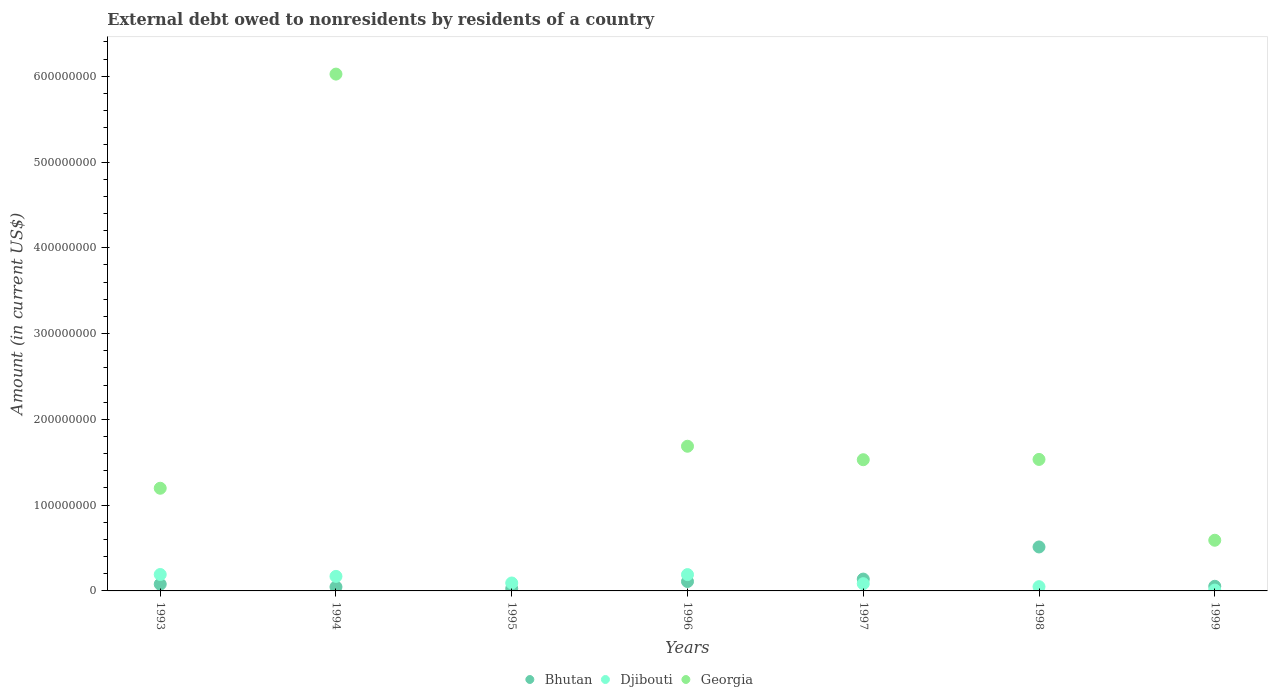What is the external debt owed by residents in Bhutan in 1995?
Provide a short and direct response. 2.72e+06. Across all years, what is the maximum external debt owed by residents in Bhutan?
Offer a terse response. 5.13e+07. Across all years, what is the minimum external debt owed by residents in Georgia?
Ensure brevity in your answer.  0. In which year was the external debt owed by residents in Djibouti maximum?
Provide a succinct answer. 1993. What is the total external debt owed by residents in Georgia in the graph?
Your answer should be compact. 1.26e+09. What is the difference between the external debt owed by residents in Djibouti in 1994 and that in 1995?
Ensure brevity in your answer.  7.70e+06. What is the difference between the external debt owed by residents in Djibouti in 1994 and the external debt owed by residents in Bhutan in 1997?
Provide a succinct answer. 3.14e+06. What is the average external debt owed by residents in Georgia per year?
Make the answer very short. 1.79e+08. In the year 1998, what is the difference between the external debt owed by residents in Djibouti and external debt owed by residents in Bhutan?
Offer a very short reply. -4.63e+07. In how many years, is the external debt owed by residents in Djibouti greater than 560000000 US$?
Your answer should be very brief. 0. What is the ratio of the external debt owed by residents in Djibouti in 1994 to that in 1997?
Keep it short and to the point. 2. Is the external debt owed by residents in Djibouti in 1994 less than that in 1999?
Give a very brief answer. No. What is the difference between the highest and the second highest external debt owed by residents in Bhutan?
Give a very brief answer. 3.75e+07. What is the difference between the highest and the lowest external debt owed by residents in Djibouti?
Keep it short and to the point. 1.82e+07. In how many years, is the external debt owed by residents in Bhutan greater than the average external debt owed by residents in Bhutan taken over all years?
Your response must be concise. 1. Is it the case that in every year, the sum of the external debt owed by residents in Bhutan and external debt owed by residents in Georgia  is greater than the external debt owed by residents in Djibouti?
Ensure brevity in your answer.  No. Does the external debt owed by residents in Bhutan monotonically increase over the years?
Your response must be concise. No. Is the external debt owed by residents in Bhutan strictly less than the external debt owed by residents in Georgia over the years?
Provide a succinct answer. No. How many dotlines are there?
Offer a very short reply. 3. Are the values on the major ticks of Y-axis written in scientific E-notation?
Offer a terse response. No. Does the graph contain grids?
Provide a succinct answer. No. How many legend labels are there?
Your response must be concise. 3. What is the title of the graph?
Offer a terse response. External debt owed to nonresidents by residents of a country. What is the label or title of the X-axis?
Make the answer very short. Years. What is the label or title of the Y-axis?
Offer a very short reply. Amount (in current US$). What is the Amount (in current US$) in Bhutan in 1993?
Offer a terse response. 7.85e+06. What is the Amount (in current US$) in Djibouti in 1993?
Your response must be concise. 1.91e+07. What is the Amount (in current US$) of Georgia in 1993?
Your answer should be compact. 1.20e+08. What is the Amount (in current US$) in Bhutan in 1994?
Provide a short and direct response. 4.67e+06. What is the Amount (in current US$) in Djibouti in 1994?
Give a very brief answer. 1.69e+07. What is the Amount (in current US$) of Georgia in 1994?
Provide a short and direct response. 6.03e+08. What is the Amount (in current US$) in Bhutan in 1995?
Keep it short and to the point. 2.72e+06. What is the Amount (in current US$) of Djibouti in 1995?
Offer a very short reply. 9.24e+06. What is the Amount (in current US$) in Bhutan in 1996?
Provide a succinct answer. 1.10e+07. What is the Amount (in current US$) of Djibouti in 1996?
Ensure brevity in your answer.  1.90e+07. What is the Amount (in current US$) in Georgia in 1996?
Keep it short and to the point. 1.69e+08. What is the Amount (in current US$) in Bhutan in 1997?
Keep it short and to the point. 1.38e+07. What is the Amount (in current US$) in Djibouti in 1997?
Ensure brevity in your answer.  8.45e+06. What is the Amount (in current US$) of Georgia in 1997?
Provide a succinct answer. 1.53e+08. What is the Amount (in current US$) in Bhutan in 1998?
Give a very brief answer. 5.13e+07. What is the Amount (in current US$) of Djibouti in 1998?
Keep it short and to the point. 4.94e+06. What is the Amount (in current US$) in Georgia in 1998?
Your response must be concise. 1.53e+08. What is the Amount (in current US$) of Bhutan in 1999?
Your answer should be compact. 5.40e+06. What is the Amount (in current US$) in Djibouti in 1999?
Provide a succinct answer. 9.88e+05. What is the Amount (in current US$) in Georgia in 1999?
Offer a very short reply. 5.91e+07. Across all years, what is the maximum Amount (in current US$) of Bhutan?
Your answer should be very brief. 5.13e+07. Across all years, what is the maximum Amount (in current US$) of Djibouti?
Your response must be concise. 1.91e+07. Across all years, what is the maximum Amount (in current US$) of Georgia?
Your response must be concise. 6.03e+08. Across all years, what is the minimum Amount (in current US$) in Bhutan?
Offer a very short reply. 2.72e+06. Across all years, what is the minimum Amount (in current US$) in Djibouti?
Your response must be concise. 9.88e+05. Across all years, what is the minimum Amount (in current US$) in Georgia?
Offer a very short reply. 0. What is the total Amount (in current US$) in Bhutan in the graph?
Offer a very short reply. 9.66e+07. What is the total Amount (in current US$) in Djibouti in the graph?
Give a very brief answer. 7.87e+07. What is the total Amount (in current US$) in Georgia in the graph?
Your answer should be very brief. 1.26e+09. What is the difference between the Amount (in current US$) of Bhutan in 1993 and that in 1994?
Offer a terse response. 3.19e+06. What is the difference between the Amount (in current US$) of Djibouti in 1993 and that in 1994?
Make the answer very short. 2.20e+06. What is the difference between the Amount (in current US$) in Georgia in 1993 and that in 1994?
Give a very brief answer. -4.83e+08. What is the difference between the Amount (in current US$) in Bhutan in 1993 and that in 1995?
Your response must be concise. 5.14e+06. What is the difference between the Amount (in current US$) in Djibouti in 1993 and that in 1995?
Provide a succinct answer. 9.91e+06. What is the difference between the Amount (in current US$) in Bhutan in 1993 and that in 1996?
Offer a terse response. -3.12e+06. What is the difference between the Amount (in current US$) of Djibouti in 1993 and that in 1996?
Ensure brevity in your answer.  1.13e+05. What is the difference between the Amount (in current US$) in Georgia in 1993 and that in 1996?
Your response must be concise. -4.90e+07. What is the difference between the Amount (in current US$) in Bhutan in 1993 and that in 1997?
Provide a short and direct response. -5.94e+06. What is the difference between the Amount (in current US$) in Djibouti in 1993 and that in 1997?
Provide a succinct answer. 1.07e+07. What is the difference between the Amount (in current US$) in Georgia in 1993 and that in 1997?
Provide a short and direct response. -3.33e+07. What is the difference between the Amount (in current US$) of Bhutan in 1993 and that in 1998?
Provide a succinct answer. -4.34e+07. What is the difference between the Amount (in current US$) of Djibouti in 1993 and that in 1998?
Ensure brevity in your answer.  1.42e+07. What is the difference between the Amount (in current US$) in Georgia in 1993 and that in 1998?
Provide a short and direct response. -3.36e+07. What is the difference between the Amount (in current US$) of Bhutan in 1993 and that in 1999?
Ensure brevity in your answer.  2.46e+06. What is the difference between the Amount (in current US$) of Djibouti in 1993 and that in 1999?
Provide a short and direct response. 1.82e+07. What is the difference between the Amount (in current US$) in Georgia in 1993 and that in 1999?
Give a very brief answer. 6.06e+07. What is the difference between the Amount (in current US$) of Bhutan in 1994 and that in 1995?
Keep it short and to the point. 1.95e+06. What is the difference between the Amount (in current US$) in Djibouti in 1994 and that in 1995?
Your answer should be compact. 7.70e+06. What is the difference between the Amount (in current US$) of Bhutan in 1994 and that in 1996?
Your answer should be very brief. -6.30e+06. What is the difference between the Amount (in current US$) of Djibouti in 1994 and that in 1996?
Your answer should be very brief. -2.09e+06. What is the difference between the Amount (in current US$) in Georgia in 1994 and that in 1996?
Your response must be concise. 4.34e+08. What is the difference between the Amount (in current US$) of Bhutan in 1994 and that in 1997?
Provide a short and direct response. -9.13e+06. What is the difference between the Amount (in current US$) of Djibouti in 1994 and that in 1997?
Keep it short and to the point. 8.49e+06. What is the difference between the Amount (in current US$) of Georgia in 1994 and that in 1997?
Your response must be concise. 4.50e+08. What is the difference between the Amount (in current US$) of Bhutan in 1994 and that in 1998?
Ensure brevity in your answer.  -4.66e+07. What is the difference between the Amount (in current US$) of Djibouti in 1994 and that in 1998?
Give a very brief answer. 1.20e+07. What is the difference between the Amount (in current US$) of Georgia in 1994 and that in 1998?
Your answer should be compact. 4.49e+08. What is the difference between the Amount (in current US$) of Bhutan in 1994 and that in 1999?
Offer a very short reply. -7.28e+05. What is the difference between the Amount (in current US$) in Djibouti in 1994 and that in 1999?
Keep it short and to the point. 1.60e+07. What is the difference between the Amount (in current US$) in Georgia in 1994 and that in 1999?
Your answer should be very brief. 5.43e+08. What is the difference between the Amount (in current US$) in Bhutan in 1995 and that in 1996?
Provide a succinct answer. -8.25e+06. What is the difference between the Amount (in current US$) in Djibouti in 1995 and that in 1996?
Your answer should be compact. -9.79e+06. What is the difference between the Amount (in current US$) in Bhutan in 1995 and that in 1997?
Provide a short and direct response. -1.11e+07. What is the difference between the Amount (in current US$) in Djibouti in 1995 and that in 1997?
Ensure brevity in your answer.  7.84e+05. What is the difference between the Amount (in current US$) in Bhutan in 1995 and that in 1998?
Provide a short and direct response. -4.85e+07. What is the difference between the Amount (in current US$) in Djibouti in 1995 and that in 1998?
Your answer should be very brief. 4.30e+06. What is the difference between the Amount (in current US$) of Bhutan in 1995 and that in 1999?
Offer a very short reply. -2.68e+06. What is the difference between the Amount (in current US$) of Djibouti in 1995 and that in 1999?
Your answer should be very brief. 8.25e+06. What is the difference between the Amount (in current US$) of Bhutan in 1996 and that in 1997?
Ensure brevity in your answer.  -2.83e+06. What is the difference between the Amount (in current US$) of Djibouti in 1996 and that in 1997?
Your answer should be compact. 1.06e+07. What is the difference between the Amount (in current US$) of Georgia in 1996 and that in 1997?
Offer a very short reply. 1.57e+07. What is the difference between the Amount (in current US$) of Bhutan in 1996 and that in 1998?
Give a very brief answer. -4.03e+07. What is the difference between the Amount (in current US$) in Djibouti in 1996 and that in 1998?
Give a very brief answer. 1.41e+07. What is the difference between the Amount (in current US$) in Georgia in 1996 and that in 1998?
Your response must be concise. 1.54e+07. What is the difference between the Amount (in current US$) in Bhutan in 1996 and that in 1999?
Provide a succinct answer. 5.57e+06. What is the difference between the Amount (in current US$) in Djibouti in 1996 and that in 1999?
Your answer should be very brief. 1.80e+07. What is the difference between the Amount (in current US$) of Georgia in 1996 and that in 1999?
Your response must be concise. 1.10e+08. What is the difference between the Amount (in current US$) of Bhutan in 1997 and that in 1998?
Your answer should be very brief. -3.75e+07. What is the difference between the Amount (in current US$) in Djibouti in 1997 and that in 1998?
Give a very brief answer. 3.51e+06. What is the difference between the Amount (in current US$) of Georgia in 1997 and that in 1998?
Make the answer very short. -3.48e+05. What is the difference between the Amount (in current US$) in Bhutan in 1997 and that in 1999?
Your response must be concise. 8.40e+06. What is the difference between the Amount (in current US$) in Djibouti in 1997 and that in 1999?
Keep it short and to the point. 7.47e+06. What is the difference between the Amount (in current US$) of Georgia in 1997 and that in 1999?
Provide a short and direct response. 9.39e+07. What is the difference between the Amount (in current US$) of Bhutan in 1998 and that in 1999?
Your answer should be very brief. 4.59e+07. What is the difference between the Amount (in current US$) of Djibouti in 1998 and that in 1999?
Make the answer very short. 3.96e+06. What is the difference between the Amount (in current US$) of Georgia in 1998 and that in 1999?
Offer a very short reply. 9.42e+07. What is the difference between the Amount (in current US$) of Bhutan in 1993 and the Amount (in current US$) of Djibouti in 1994?
Give a very brief answer. -9.09e+06. What is the difference between the Amount (in current US$) of Bhutan in 1993 and the Amount (in current US$) of Georgia in 1994?
Provide a short and direct response. -5.95e+08. What is the difference between the Amount (in current US$) of Djibouti in 1993 and the Amount (in current US$) of Georgia in 1994?
Provide a short and direct response. -5.83e+08. What is the difference between the Amount (in current US$) in Bhutan in 1993 and the Amount (in current US$) in Djibouti in 1995?
Provide a succinct answer. -1.38e+06. What is the difference between the Amount (in current US$) in Bhutan in 1993 and the Amount (in current US$) in Djibouti in 1996?
Make the answer very short. -1.12e+07. What is the difference between the Amount (in current US$) in Bhutan in 1993 and the Amount (in current US$) in Georgia in 1996?
Make the answer very short. -1.61e+08. What is the difference between the Amount (in current US$) in Djibouti in 1993 and the Amount (in current US$) in Georgia in 1996?
Your response must be concise. -1.50e+08. What is the difference between the Amount (in current US$) in Bhutan in 1993 and the Amount (in current US$) in Djibouti in 1997?
Your answer should be compact. -6.00e+05. What is the difference between the Amount (in current US$) of Bhutan in 1993 and the Amount (in current US$) of Georgia in 1997?
Give a very brief answer. -1.45e+08. What is the difference between the Amount (in current US$) of Djibouti in 1993 and the Amount (in current US$) of Georgia in 1997?
Ensure brevity in your answer.  -1.34e+08. What is the difference between the Amount (in current US$) in Bhutan in 1993 and the Amount (in current US$) in Djibouti in 1998?
Offer a terse response. 2.91e+06. What is the difference between the Amount (in current US$) of Bhutan in 1993 and the Amount (in current US$) of Georgia in 1998?
Provide a succinct answer. -1.45e+08. What is the difference between the Amount (in current US$) of Djibouti in 1993 and the Amount (in current US$) of Georgia in 1998?
Your response must be concise. -1.34e+08. What is the difference between the Amount (in current US$) in Bhutan in 1993 and the Amount (in current US$) in Djibouti in 1999?
Your answer should be very brief. 6.87e+06. What is the difference between the Amount (in current US$) in Bhutan in 1993 and the Amount (in current US$) in Georgia in 1999?
Give a very brief answer. -5.12e+07. What is the difference between the Amount (in current US$) of Djibouti in 1993 and the Amount (in current US$) of Georgia in 1999?
Make the answer very short. -3.99e+07. What is the difference between the Amount (in current US$) of Bhutan in 1994 and the Amount (in current US$) of Djibouti in 1995?
Offer a very short reply. -4.57e+06. What is the difference between the Amount (in current US$) in Bhutan in 1994 and the Amount (in current US$) in Djibouti in 1996?
Your answer should be compact. -1.44e+07. What is the difference between the Amount (in current US$) in Bhutan in 1994 and the Amount (in current US$) in Georgia in 1996?
Offer a very short reply. -1.64e+08. What is the difference between the Amount (in current US$) in Djibouti in 1994 and the Amount (in current US$) in Georgia in 1996?
Offer a terse response. -1.52e+08. What is the difference between the Amount (in current US$) in Bhutan in 1994 and the Amount (in current US$) in Djibouti in 1997?
Your answer should be compact. -3.79e+06. What is the difference between the Amount (in current US$) in Bhutan in 1994 and the Amount (in current US$) in Georgia in 1997?
Your answer should be compact. -1.48e+08. What is the difference between the Amount (in current US$) of Djibouti in 1994 and the Amount (in current US$) of Georgia in 1997?
Offer a terse response. -1.36e+08. What is the difference between the Amount (in current US$) in Bhutan in 1994 and the Amount (in current US$) in Djibouti in 1998?
Your response must be concise. -2.76e+05. What is the difference between the Amount (in current US$) in Bhutan in 1994 and the Amount (in current US$) in Georgia in 1998?
Provide a succinct answer. -1.49e+08. What is the difference between the Amount (in current US$) of Djibouti in 1994 and the Amount (in current US$) of Georgia in 1998?
Provide a short and direct response. -1.36e+08. What is the difference between the Amount (in current US$) in Bhutan in 1994 and the Amount (in current US$) in Djibouti in 1999?
Keep it short and to the point. 3.68e+06. What is the difference between the Amount (in current US$) of Bhutan in 1994 and the Amount (in current US$) of Georgia in 1999?
Provide a succinct answer. -5.44e+07. What is the difference between the Amount (in current US$) of Djibouti in 1994 and the Amount (in current US$) of Georgia in 1999?
Your answer should be compact. -4.21e+07. What is the difference between the Amount (in current US$) of Bhutan in 1995 and the Amount (in current US$) of Djibouti in 1996?
Provide a short and direct response. -1.63e+07. What is the difference between the Amount (in current US$) in Bhutan in 1995 and the Amount (in current US$) in Georgia in 1996?
Keep it short and to the point. -1.66e+08. What is the difference between the Amount (in current US$) in Djibouti in 1995 and the Amount (in current US$) in Georgia in 1996?
Give a very brief answer. -1.59e+08. What is the difference between the Amount (in current US$) of Bhutan in 1995 and the Amount (in current US$) of Djibouti in 1997?
Ensure brevity in your answer.  -5.74e+06. What is the difference between the Amount (in current US$) in Bhutan in 1995 and the Amount (in current US$) in Georgia in 1997?
Keep it short and to the point. -1.50e+08. What is the difference between the Amount (in current US$) of Djibouti in 1995 and the Amount (in current US$) of Georgia in 1997?
Provide a succinct answer. -1.44e+08. What is the difference between the Amount (in current US$) in Bhutan in 1995 and the Amount (in current US$) in Djibouti in 1998?
Your answer should be very brief. -2.23e+06. What is the difference between the Amount (in current US$) in Bhutan in 1995 and the Amount (in current US$) in Georgia in 1998?
Your answer should be very brief. -1.51e+08. What is the difference between the Amount (in current US$) in Djibouti in 1995 and the Amount (in current US$) in Georgia in 1998?
Offer a terse response. -1.44e+08. What is the difference between the Amount (in current US$) of Bhutan in 1995 and the Amount (in current US$) of Djibouti in 1999?
Your answer should be very brief. 1.73e+06. What is the difference between the Amount (in current US$) of Bhutan in 1995 and the Amount (in current US$) of Georgia in 1999?
Give a very brief answer. -5.64e+07. What is the difference between the Amount (in current US$) in Djibouti in 1995 and the Amount (in current US$) in Georgia in 1999?
Make the answer very short. -4.98e+07. What is the difference between the Amount (in current US$) of Bhutan in 1996 and the Amount (in current US$) of Djibouti in 1997?
Offer a terse response. 2.52e+06. What is the difference between the Amount (in current US$) in Bhutan in 1996 and the Amount (in current US$) in Georgia in 1997?
Offer a terse response. -1.42e+08. What is the difference between the Amount (in current US$) of Djibouti in 1996 and the Amount (in current US$) of Georgia in 1997?
Keep it short and to the point. -1.34e+08. What is the difference between the Amount (in current US$) in Bhutan in 1996 and the Amount (in current US$) in Djibouti in 1998?
Your answer should be compact. 6.03e+06. What is the difference between the Amount (in current US$) in Bhutan in 1996 and the Amount (in current US$) in Georgia in 1998?
Offer a terse response. -1.42e+08. What is the difference between the Amount (in current US$) of Djibouti in 1996 and the Amount (in current US$) of Georgia in 1998?
Offer a very short reply. -1.34e+08. What is the difference between the Amount (in current US$) in Bhutan in 1996 and the Amount (in current US$) in Djibouti in 1999?
Your response must be concise. 9.98e+06. What is the difference between the Amount (in current US$) in Bhutan in 1996 and the Amount (in current US$) in Georgia in 1999?
Your answer should be compact. -4.81e+07. What is the difference between the Amount (in current US$) in Djibouti in 1996 and the Amount (in current US$) in Georgia in 1999?
Provide a short and direct response. -4.00e+07. What is the difference between the Amount (in current US$) in Bhutan in 1997 and the Amount (in current US$) in Djibouti in 1998?
Your response must be concise. 8.85e+06. What is the difference between the Amount (in current US$) in Bhutan in 1997 and the Amount (in current US$) in Georgia in 1998?
Make the answer very short. -1.40e+08. What is the difference between the Amount (in current US$) in Djibouti in 1997 and the Amount (in current US$) in Georgia in 1998?
Provide a short and direct response. -1.45e+08. What is the difference between the Amount (in current US$) in Bhutan in 1997 and the Amount (in current US$) in Djibouti in 1999?
Give a very brief answer. 1.28e+07. What is the difference between the Amount (in current US$) in Bhutan in 1997 and the Amount (in current US$) in Georgia in 1999?
Offer a terse response. -4.53e+07. What is the difference between the Amount (in current US$) of Djibouti in 1997 and the Amount (in current US$) of Georgia in 1999?
Give a very brief answer. -5.06e+07. What is the difference between the Amount (in current US$) of Bhutan in 1998 and the Amount (in current US$) of Djibouti in 1999?
Offer a very short reply. 5.03e+07. What is the difference between the Amount (in current US$) in Bhutan in 1998 and the Amount (in current US$) in Georgia in 1999?
Make the answer very short. -7.82e+06. What is the difference between the Amount (in current US$) in Djibouti in 1998 and the Amount (in current US$) in Georgia in 1999?
Give a very brief answer. -5.41e+07. What is the average Amount (in current US$) of Bhutan per year?
Ensure brevity in your answer.  1.38e+07. What is the average Amount (in current US$) of Djibouti per year?
Ensure brevity in your answer.  1.12e+07. What is the average Amount (in current US$) of Georgia per year?
Your answer should be compact. 1.79e+08. In the year 1993, what is the difference between the Amount (in current US$) of Bhutan and Amount (in current US$) of Djibouti?
Your answer should be very brief. -1.13e+07. In the year 1993, what is the difference between the Amount (in current US$) in Bhutan and Amount (in current US$) in Georgia?
Give a very brief answer. -1.12e+08. In the year 1993, what is the difference between the Amount (in current US$) in Djibouti and Amount (in current US$) in Georgia?
Make the answer very short. -1.01e+08. In the year 1994, what is the difference between the Amount (in current US$) of Bhutan and Amount (in current US$) of Djibouti?
Keep it short and to the point. -1.23e+07. In the year 1994, what is the difference between the Amount (in current US$) in Bhutan and Amount (in current US$) in Georgia?
Keep it short and to the point. -5.98e+08. In the year 1994, what is the difference between the Amount (in current US$) of Djibouti and Amount (in current US$) of Georgia?
Your answer should be very brief. -5.86e+08. In the year 1995, what is the difference between the Amount (in current US$) in Bhutan and Amount (in current US$) in Djibouti?
Offer a very short reply. -6.52e+06. In the year 1996, what is the difference between the Amount (in current US$) in Bhutan and Amount (in current US$) in Djibouti?
Make the answer very short. -8.06e+06. In the year 1996, what is the difference between the Amount (in current US$) in Bhutan and Amount (in current US$) in Georgia?
Ensure brevity in your answer.  -1.58e+08. In the year 1996, what is the difference between the Amount (in current US$) in Djibouti and Amount (in current US$) in Georgia?
Your answer should be compact. -1.50e+08. In the year 1997, what is the difference between the Amount (in current US$) of Bhutan and Amount (in current US$) of Djibouti?
Offer a terse response. 5.34e+06. In the year 1997, what is the difference between the Amount (in current US$) in Bhutan and Amount (in current US$) in Georgia?
Offer a very short reply. -1.39e+08. In the year 1997, what is the difference between the Amount (in current US$) of Djibouti and Amount (in current US$) of Georgia?
Make the answer very short. -1.44e+08. In the year 1998, what is the difference between the Amount (in current US$) of Bhutan and Amount (in current US$) of Djibouti?
Your response must be concise. 4.63e+07. In the year 1998, what is the difference between the Amount (in current US$) of Bhutan and Amount (in current US$) of Georgia?
Your answer should be very brief. -1.02e+08. In the year 1998, what is the difference between the Amount (in current US$) in Djibouti and Amount (in current US$) in Georgia?
Provide a succinct answer. -1.48e+08. In the year 1999, what is the difference between the Amount (in current US$) in Bhutan and Amount (in current US$) in Djibouti?
Your answer should be very brief. 4.41e+06. In the year 1999, what is the difference between the Amount (in current US$) of Bhutan and Amount (in current US$) of Georgia?
Provide a succinct answer. -5.37e+07. In the year 1999, what is the difference between the Amount (in current US$) in Djibouti and Amount (in current US$) in Georgia?
Make the answer very short. -5.81e+07. What is the ratio of the Amount (in current US$) in Bhutan in 1993 to that in 1994?
Provide a succinct answer. 1.68. What is the ratio of the Amount (in current US$) of Djibouti in 1993 to that in 1994?
Keep it short and to the point. 1.13. What is the ratio of the Amount (in current US$) of Georgia in 1993 to that in 1994?
Offer a very short reply. 0.2. What is the ratio of the Amount (in current US$) of Bhutan in 1993 to that in 1995?
Make the answer very short. 2.89. What is the ratio of the Amount (in current US$) in Djibouti in 1993 to that in 1995?
Keep it short and to the point. 2.07. What is the ratio of the Amount (in current US$) in Bhutan in 1993 to that in 1996?
Provide a short and direct response. 0.72. What is the ratio of the Amount (in current US$) of Djibouti in 1993 to that in 1996?
Offer a terse response. 1.01. What is the ratio of the Amount (in current US$) of Georgia in 1993 to that in 1996?
Your answer should be compact. 0.71. What is the ratio of the Amount (in current US$) in Bhutan in 1993 to that in 1997?
Your answer should be compact. 0.57. What is the ratio of the Amount (in current US$) of Djibouti in 1993 to that in 1997?
Your answer should be compact. 2.26. What is the ratio of the Amount (in current US$) of Georgia in 1993 to that in 1997?
Your response must be concise. 0.78. What is the ratio of the Amount (in current US$) of Bhutan in 1993 to that in 1998?
Offer a very short reply. 0.15. What is the ratio of the Amount (in current US$) in Djibouti in 1993 to that in 1998?
Your answer should be compact. 3.87. What is the ratio of the Amount (in current US$) of Georgia in 1993 to that in 1998?
Your answer should be compact. 0.78. What is the ratio of the Amount (in current US$) of Bhutan in 1993 to that in 1999?
Offer a very short reply. 1.46. What is the ratio of the Amount (in current US$) of Djibouti in 1993 to that in 1999?
Give a very brief answer. 19.38. What is the ratio of the Amount (in current US$) of Georgia in 1993 to that in 1999?
Give a very brief answer. 2.03. What is the ratio of the Amount (in current US$) of Bhutan in 1994 to that in 1995?
Give a very brief answer. 1.72. What is the ratio of the Amount (in current US$) in Djibouti in 1994 to that in 1995?
Make the answer very short. 1.83. What is the ratio of the Amount (in current US$) in Bhutan in 1994 to that in 1996?
Provide a short and direct response. 0.43. What is the ratio of the Amount (in current US$) of Djibouti in 1994 to that in 1996?
Your answer should be compact. 0.89. What is the ratio of the Amount (in current US$) in Georgia in 1994 to that in 1996?
Offer a terse response. 3.57. What is the ratio of the Amount (in current US$) in Bhutan in 1994 to that in 1997?
Your answer should be very brief. 0.34. What is the ratio of the Amount (in current US$) in Djibouti in 1994 to that in 1997?
Give a very brief answer. 2. What is the ratio of the Amount (in current US$) of Georgia in 1994 to that in 1997?
Offer a very short reply. 3.94. What is the ratio of the Amount (in current US$) in Bhutan in 1994 to that in 1998?
Offer a very short reply. 0.09. What is the ratio of the Amount (in current US$) in Djibouti in 1994 to that in 1998?
Provide a short and direct response. 3.43. What is the ratio of the Amount (in current US$) in Georgia in 1994 to that in 1998?
Provide a succinct answer. 3.93. What is the ratio of the Amount (in current US$) of Bhutan in 1994 to that in 1999?
Give a very brief answer. 0.87. What is the ratio of the Amount (in current US$) in Djibouti in 1994 to that in 1999?
Give a very brief answer. 17.15. What is the ratio of the Amount (in current US$) of Georgia in 1994 to that in 1999?
Give a very brief answer. 10.2. What is the ratio of the Amount (in current US$) in Bhutan in 1995 to that in 1996?
Provide a succinct answer. 0.25. What is the ratio of the Amount (in current US$) of Djibouti in 1995 to that in 1996?
Your answer should be compact. 0.49. What is the ratio of the Amount (in current US$) of Bhutan in 1995 to that in 1997?
Provide a succinct answer. 0.2. What is the ratio of the Amount (in current US$) of Djibouti in 1995 to that in 1997?
Keep it short and to the point. 1.09. What is the ratio of the Amount (in current US$) in Bhutan in 1995 to that in 1998?
Offer a terse response. 0.05. What is the ratio of the Amount (in current US$) in Djibouti in 1995 to that in 1998?
Make the answer very short. 1.87. What is the ratio of the Amount (in current US$) of Bhutan in 1995 to that in 1999?
Make the answer very short. 0.5. What is the ratio of the Amount (in current US$) of Djibouti in 1995 to that in 1999?
Offer a terse response. 9.35. What is the ratio of the Amount (in current US$) of Bhutan in 1996 to that in 1997?
Give a very brief answer. 0.8. What is the ratio of the Amount (in current US$) of Djibouti in 1996 to that in 1997?
Ensure brevity in your answer.  2.25. What is the ratio of the Amount (in current US$) in Georgia in 1996 to that in 1997?
Ensure brevity in your answer.  1.1. What is the ratio of the Amount (in current US$) of Bhutan in 1996 to that in 1998?
Your answer should be very brief. 0.21. What is the ratio of the Amount (in current US$) in Djibouti in 1996 to that in 1998?
Provide a short and direct response. 3.85. What is the ratio of the Amount (in current US$) in Georgia in 1996 to that in 1998?
Offer a terse response. 1.1. What is the ratio of the Amount (in current US$) of Bhutan in 1996 to that in 1999?
Offer a very short reply. 2.03. What is the ratio of the Amount (in current US$) of Djibouti in 1996 to that in 1999?
Your answer should be compact. 19.26. What is the ratio of the Amount (in current US$) in Georgia in 1996 to that in 1999?
Keep it short and to the point. 2.86. What is the ratio of the Amount (in current US$) in Bhutan in 1997 to that in 1998?
Give a very brief answer. 0.27. What is the ratio of the Amount (in current US$) of Djibouti in 1997 to that in 1998?
Provide a succinct answer. 1.71. What is the ratio of the Amount (in current US$) of Bhutan in 1997 to that in 1999?
Provide a succinct answer. 2.56. What is the ratio of the Amount (in current US$) of Djibouti in 1997 to that in 1999?
Offer a terse response. 8.56. What is the ratio of the Amount (in current US$) of Georgia in 1997 to that in 1999?
Your response must be concise. 2.59. What is the ratio of the Amount (in current US$) in Bhutan in 1998 to that in 1999?
Provide a short and direct response. 9.5. What is the ratio of the Amount (in current US$) of Djibouti in 1998 to that in 1999?
Offer a very short reply. 5. What is the ratio of the Amount (in current US$) of Georgia in 1998 to that in 1999?
Provide a succinct answer. 2.6. What is the difference between the highest and the second highest Amount (in current US$) in Bhutan?
Provide a short and direct response. 3.75e+07. What is the difference between the highest and the second highest Amount (in current US$) in Djibouti?
Ensure brevity in your answer.  1.13e+05. What is the difference between the highest and the second highest Amount (in current US$) of Georgia?
Make the answer very short. 4.34e+08. What is the difference between the highest and the lowest Amount (in current US$) of Bhutan?
Make the answer very short. 4.85e+07. What is the difference between the highest and the lowest Amount (in current US$) of Djibouti?
Ensure brevity in your answer.  1.82e+07. What is the difference between the highest and the lowest Amount (in current US$) of Georgia?
Keep it short and to the point. 6.03e+08. 